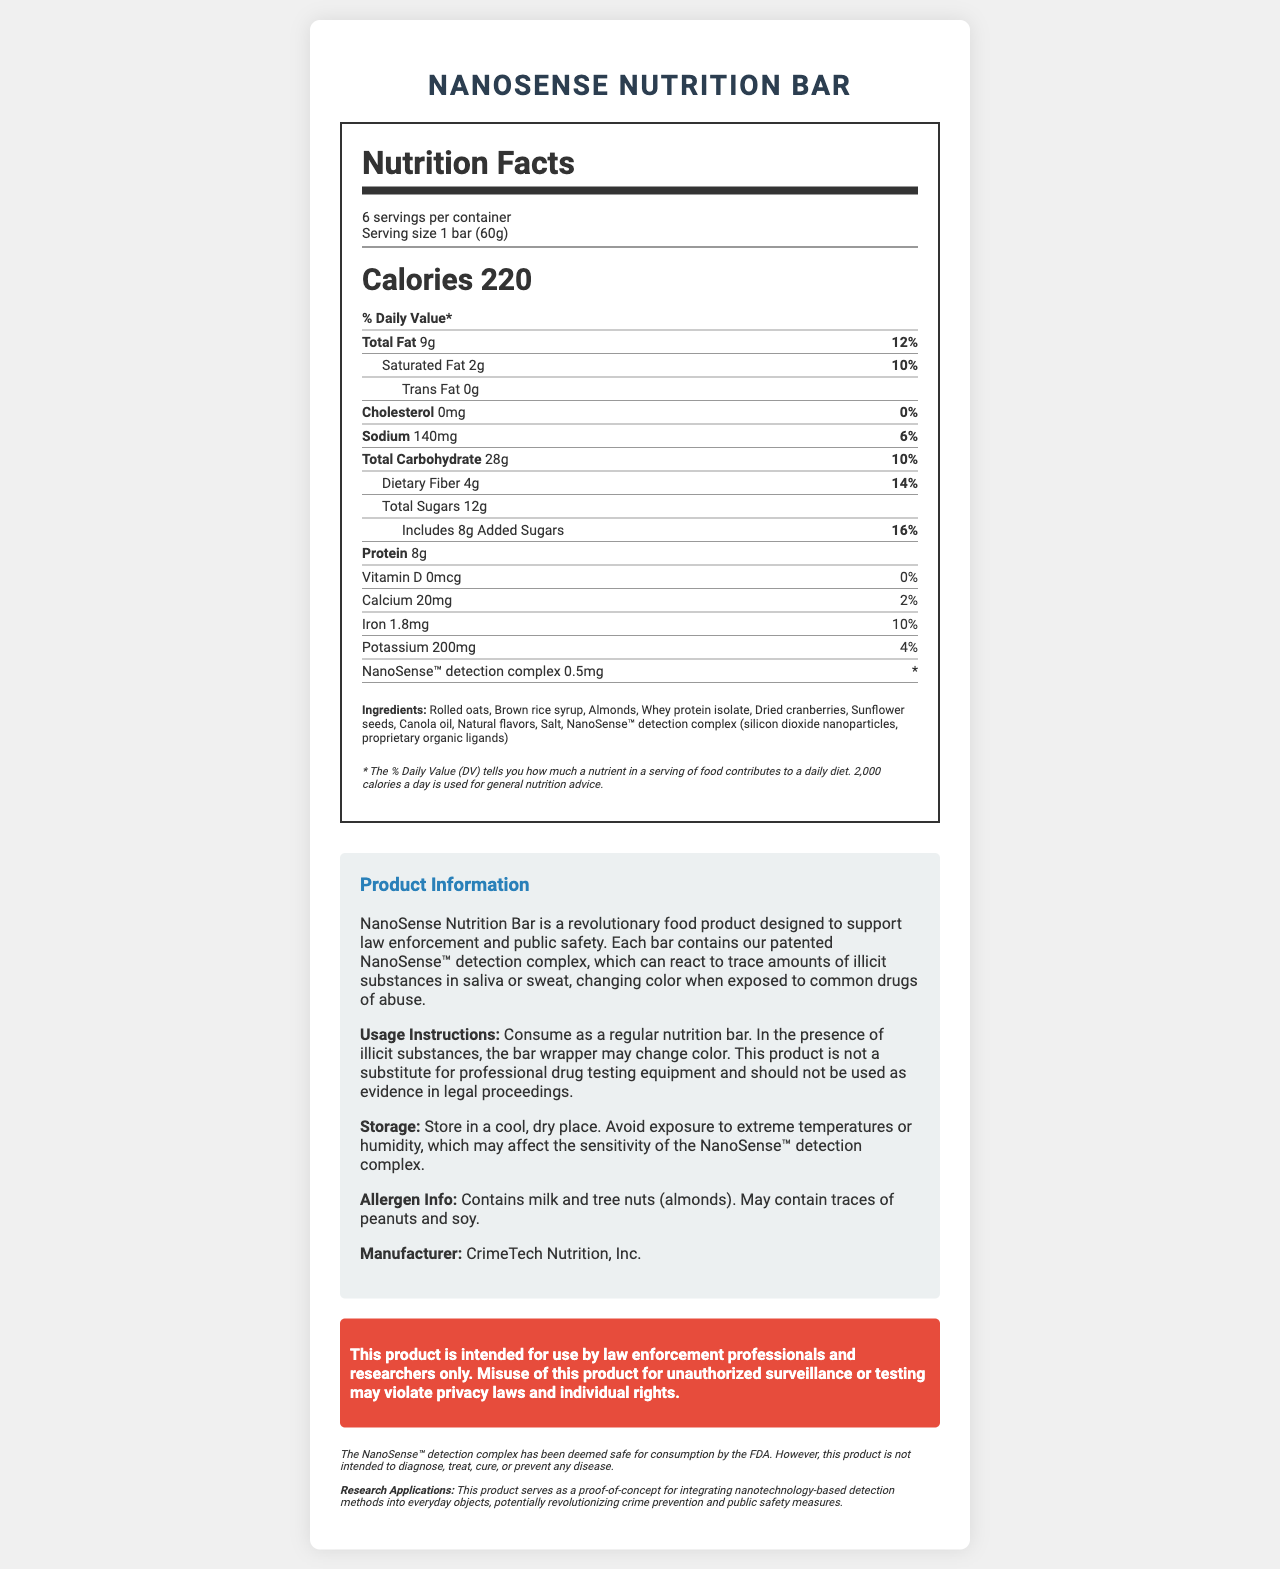what is the serving size of the NanoSense Nutrition Bar? The serving size is clearly stated as "1 bar (60g)" under the Nutrition Facts label.
Answer: 1 bar (60g) how many calories are in one serving of the NanoSense Nutrition Bar? The Nutrition Facts label lists the calorie content per serving as 220 calories.
Answer: 220 which ingredient in the NanoSense Nutrition Bar may help with protein intake? Among the ingredients listed, whey protein isolate is known for its high protein content.
Answer: Whey protein isolate does the NanoSense Nutrition Bar contain any trans fat? The document states that the trans fat content is "0g".
Answer: No what is the purpose of the patented NanoSense™ detection complex in the bar? The product description explains that the NanoSense™ detection complex can react to trace amounts of illicit substances, changing color when exposed to common drugs of abuse.
Answer: Detect traces of illicit substances how many servings are in one container of the NanoSense Nutrition Bar? A. 8 B. 6 C. 4 D. 10 The serving information section specifies "6 servings per container".
Answer: B. 6 what percentage of daily value does dietary fiber contribute? A. 8% B. 10% C. 14% D. 18% Under Total Carbohydrate, the daily value percentage for dietary fiber is listed as 14%.
Answer: C. 14% is the NanoSense™ detection complex safe for human consumption? It is stated that the NanoSense™ detection complex has been deemed safe for consumption by the FDA.
Answer: Yes can the NanoSense Nutrition Bar be used as official evidence in legal proceedings? The usage instructions specify that the product should not be used as evidence in legal proceedings.
Answer: No summarize the main purpose and features of the NanoSense Nutrition Bar. This summary captures the nutrition, detection functionality, and practical use aspects described in the document.
Answer: The NanoSense Nutrition Bar is a novel food product designed to aid law enforcement and public safety by detecting traces of illicit substances through a patented nanoparticle complex, while also providing nutritional benefits. It contains 220 calories per serving, with ingredients like rolled oats and whey protein isolate. It includes a NanoSense™ detection complex to indicate the presence of drugs in saliva or sweat via color change. The product is not intended for legal evidence and is safe for consumption according to the FDA. how should the NanoSense Nutrition Bar be stored to maintain its detection capabilities? The storage instructions emphasize the importance of a cool, dry environment to prevent degradation of the nanoparticle complex.
Answer: Store in a cool, dry place. Avoid exposure to extreme temperatures or humidity, which may affect the sensitivity of the NanoSense™ detection complex. what are the ingredients in the NanoSense™ detection complex? The ingredients list explicitly mentions the components of the NanoSense™ detection complex.
Answer: Silicon dioxide nanoparticles, proprietary organic ligands who manufactures the NanoSense Nutrition Bar? The manufacturer is stated as CrimeTech Nutrition, Inc. in the product information section.
Answer: CrimeTech Nutrition, Inc. why could the NanoSense Nutrition Bar be considered a revolution in crime prevention? The research applications section highlights the innovative aspect of integrating detection capabilities into a consumable product for crime prevention.
Answer: It integrates nanotechnology-based detection methods into everyday objects, potentially revolutionizing crime prevention and public safety measures by detecting illicit substances. what is the amount of added sugars in one serving of the NanoSense Nutrition Bar? The Nutrition Facts label shows that the added sugars content is 8g.
Answer: 8g what percentage of your daily iron intake does one NanoSense Nutrition Bar provide? The Nutrition Facts label states that the bar provides 10% of the daily value for iron.
Answer: 10% can the NanoSense Nutrition Bar detect all types of illicit substances? The document mentions the bar can detect common drugs of abuse, but it doesn't specify all types of illicit substances it can detect.
Answer: Not enough information 